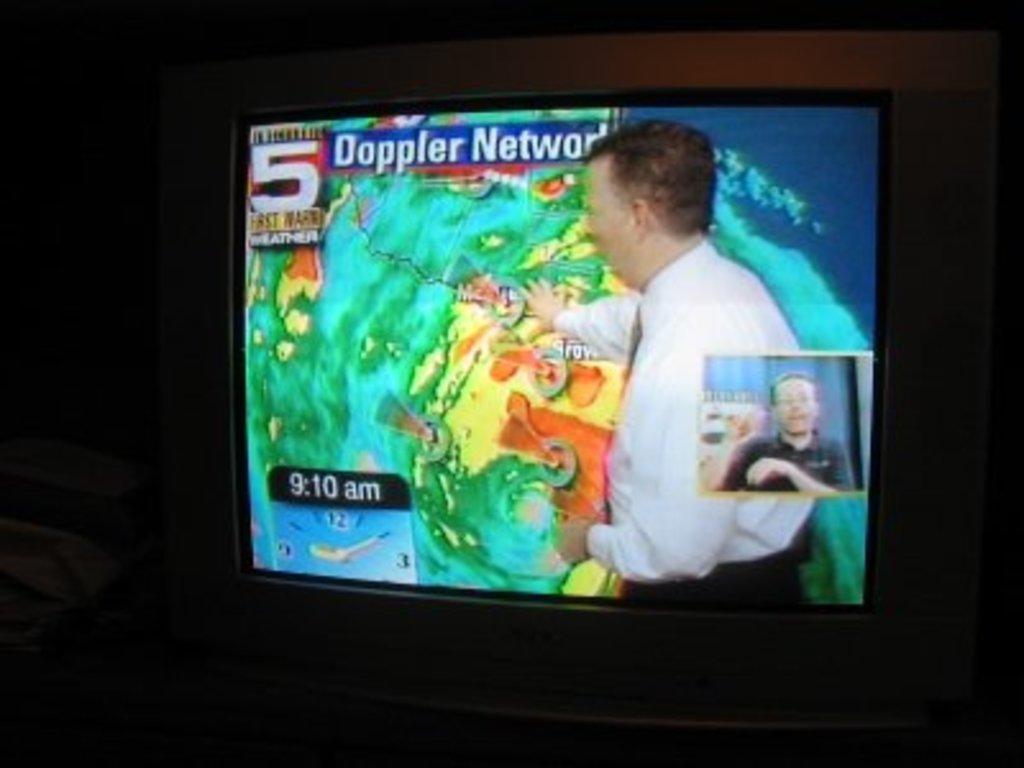Describe this image in one or two sentences. In the image we can see the television screen. In it we can see two people wearing clothes and there is even the text. 